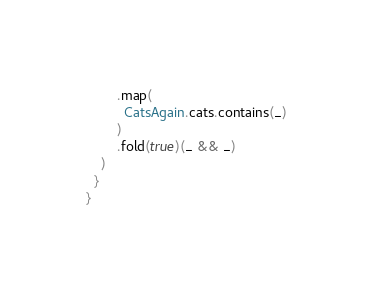Convert code to text. <code><loc_0><loc_0><loc_500><loc_500><_Scala_>        .map(
          CatsAgain.cats.contains(_)
        )
        .fold(true)(_ && _)
    )
  }
}
</code> 